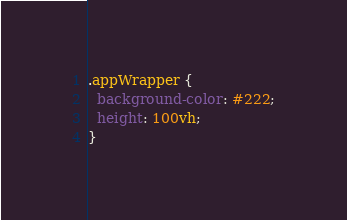<code> <loc_0><loc_0><loc_500><loc_500><_CSS_>.appWrapper {
  background-color: #222;
  height: 100vh;
}
</code> 